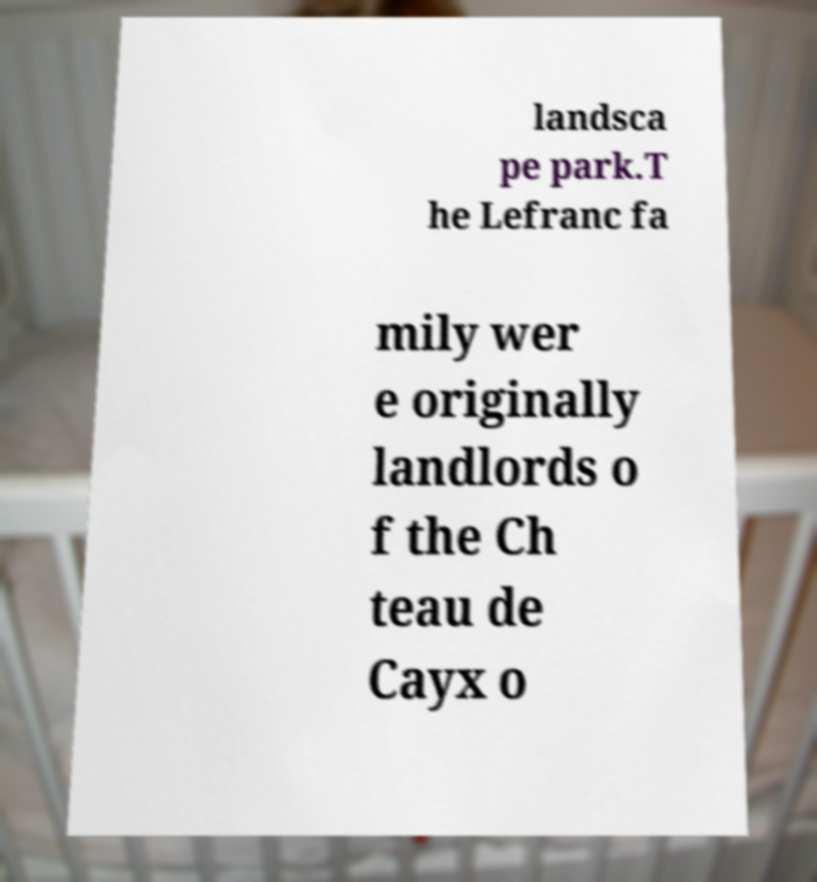Can you accurately transcribe the text from the provided image for me? landsca pe park.T he Lefranc fa mily wer e originally landlords o f the Ch teau de Cayx o 